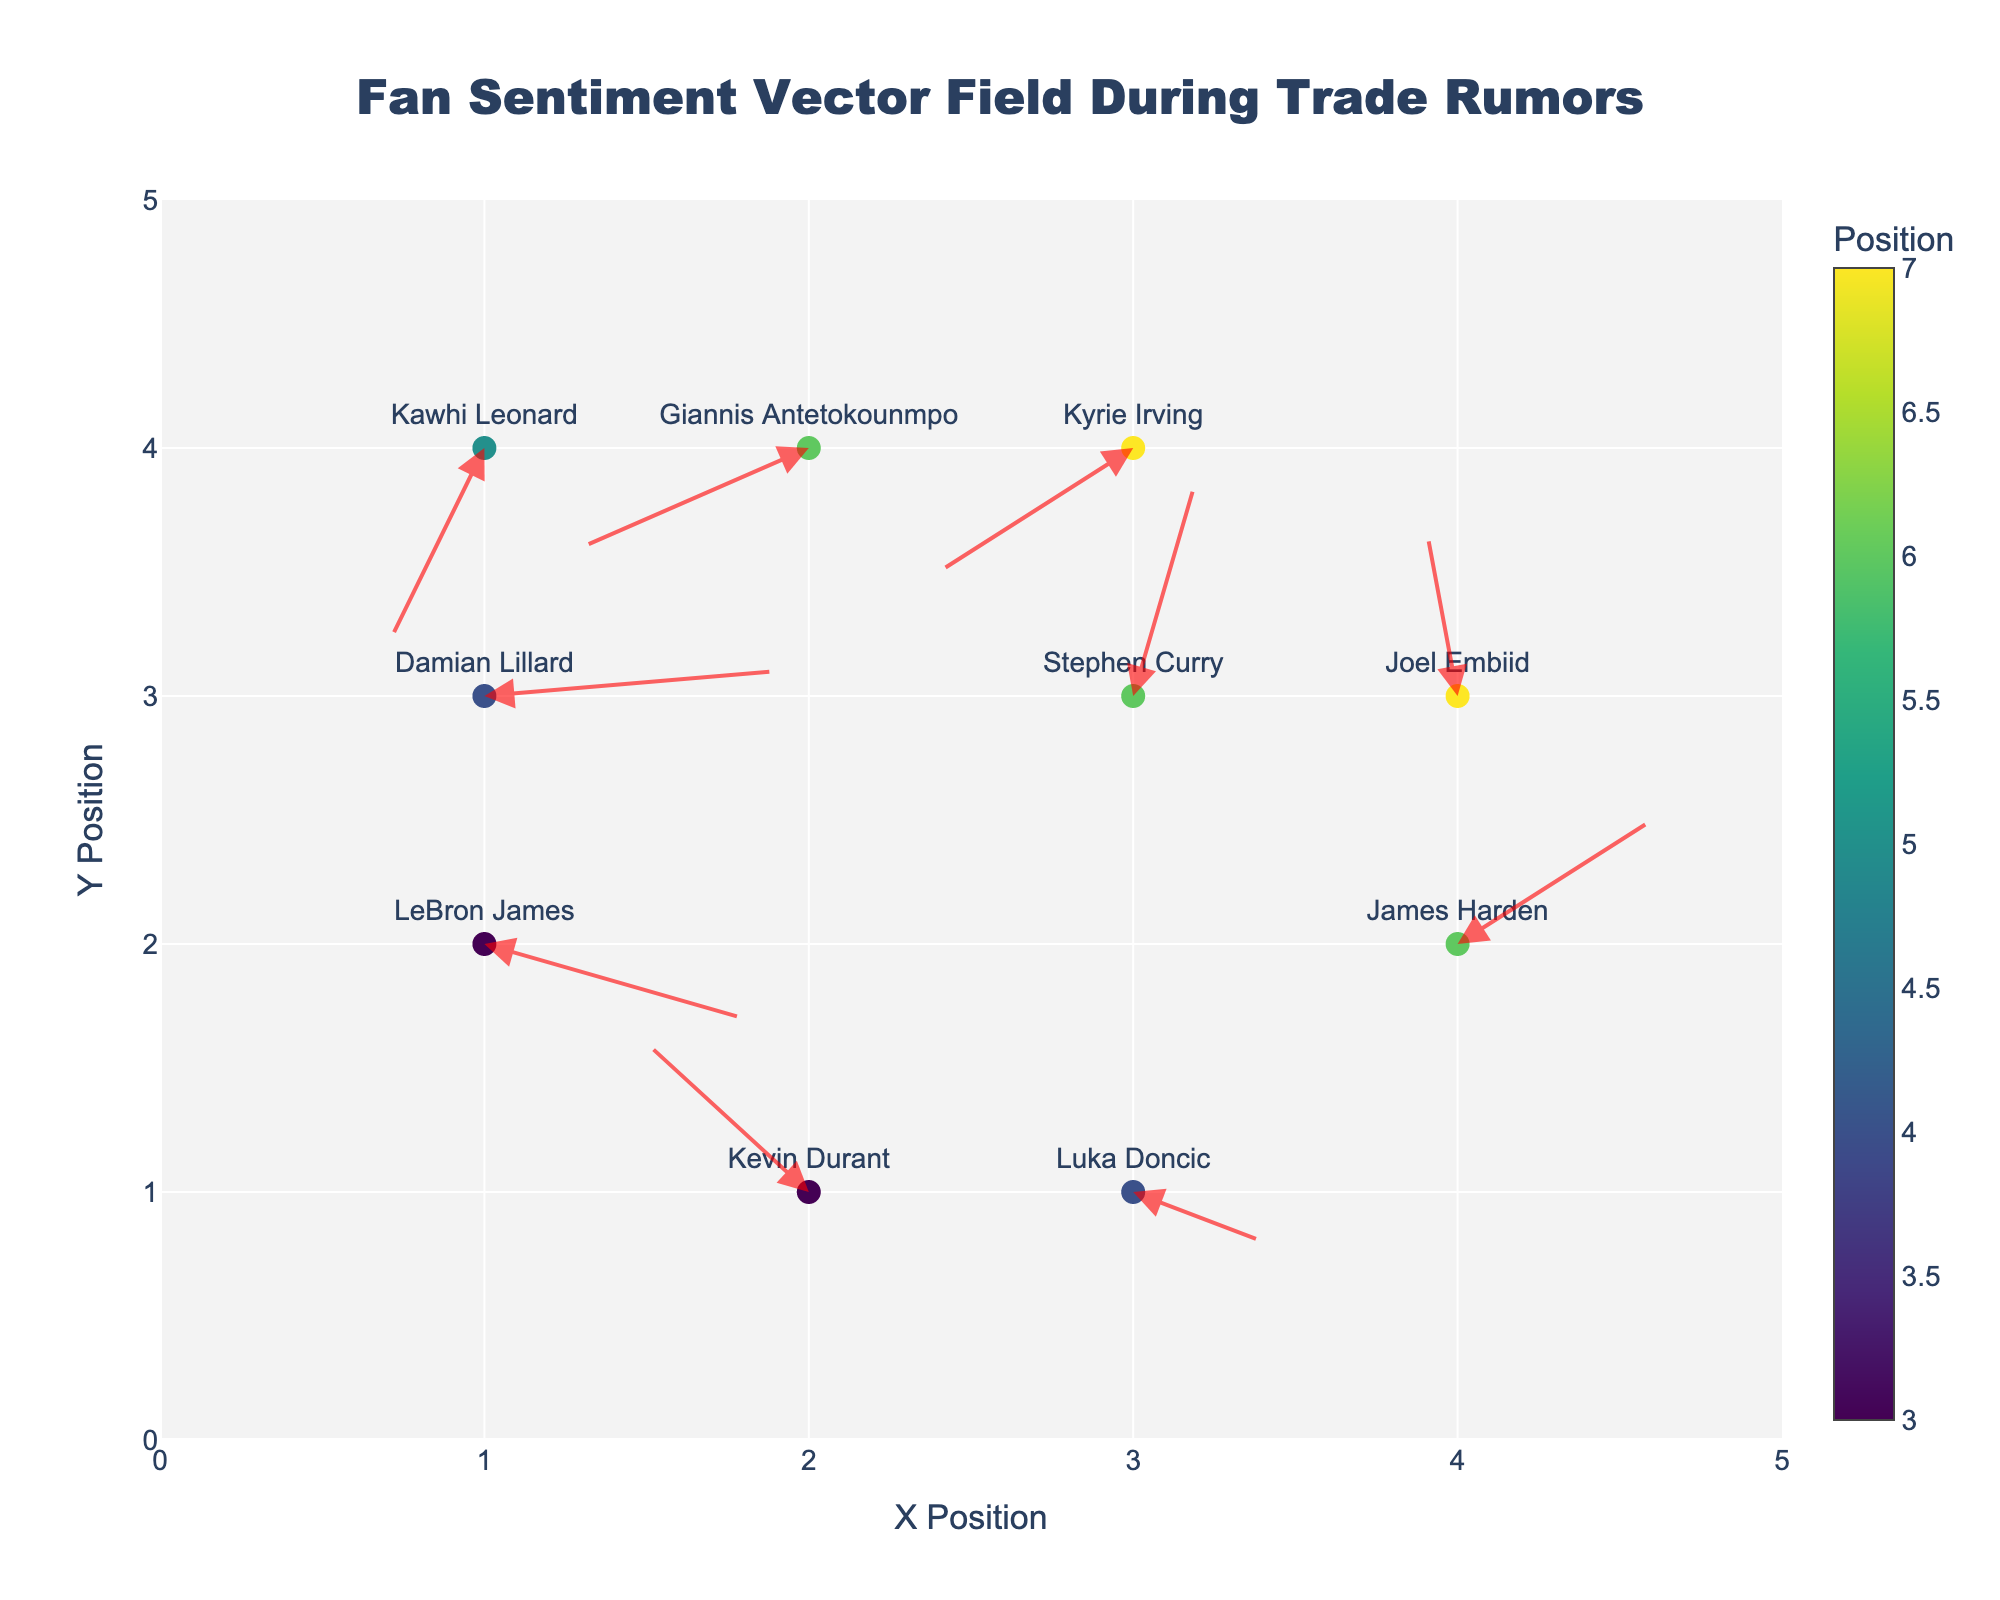What is the title of the quiver plot? The title is usually displayed prominently at the top center of the plot. In this case, it is "Fan Sentiment Vector Field During Trade Rumors" based on the figure's description.
Answer: "Fan Sentiment Vector Field During Trade Rumors" Which player has the highest X position in the plot? By referring to the player labels and their respective X positions, LeBron James has X = 1, Kevin Durant has X = 2, Stephen Curry has X = 3, Giannis Antetokounmpo has X = 2, James Harden has X = 4, and so on. James Harden, with X = 4, has the highest X position.
Answer: James Harden Which player shows the strongest negative sentiment (largest negative vector)? The direction and length of the sentiment vectors (U, V) can indicate the strength of the sentiment. The most negative combination is evidenced by the largest total vector magnitude in the negative direction. Kawhi Leonard has U = -0.3 and V = -0.8, giving a vector magnitude of √((-0.3)^2 + (-0.8)^2) ≈ 0.854.
Answer: Kawhi Leonard For Damian Lillard, what is the direction of the sentiment vector? Damian Lillard is located at X = 1, Y = 3 with vector components U = 0.9 and V = 0.1. The direction can be interpreted as predominantly positive in the horizontal (X) direction and slightly positive in the vertical (Y) direction.
Answer: Mostly positive horizontal, slightly positive vertical Which player shows a sentiment vector moving northwest (negative X, positive Y)? By analyzing the players and their sentiment vectors, Kevin Durant at X = 2, Y = 1 with U = -0.5 and V = 0.6 has a vector moving in the northwest direction.
Answer: Kevin Durant What is the average Y position of all players? Sum all Y positions: 2+1+3+4+2+4+1+3+3+4 = 27. There are 10 players, so the average is 27/10 = 2.7.
Answer: 2.7 Who has the longest sentiment vector? Calculate the magnitude of each sentiment vector using √(U^2 + V^2). For example, LeBron James's vector has a magnitude of √((0.8)^2 + (-0.3)^2) ≈ 0.854, and Stephen Curry's vector has √((0.2)^2 + (0.9)^2) ≈ 0.922. Stephen Curry with √((0.2)^2 + (0.9)^2) ≈ 0.922 has the longest vector.
Answer: Stephen Curry Compare the sentiment vectors of Stephen Curry and Kyrie Irving in terms of direction. Stephen Curry (X = 3, Y = 3) has a vector (U = 0.2, V = 0.9) moving mostly upwards, while Kyrie Irving (X = 3, Y = 4) has a vector (U = -0.6, V = -0.5) moving mostly downwards and to the left.
Answer: Stephen Curry's vector is mostly upwards, Kyrie Irving's vector is downwards and to the left Which player stands at position (4, 3)? By checking the list of player positions, Joel Embiid is at position (4, 3).
Answer: Joel Embiid Between LeBron James and Damian Lillard, who has the more positive sentiment? Compare the sentiment vectors: LeBron James (X = 1, Y = 2) with vector (U = 0.8, V = -0.3) and Damian Lillard (X = 1, Y = 3) with vector (U = 0.9, V = 0.1). Both vectors have positive X components, but Damian Lillard's vector has a positive Y component, indicating a more positive sentiment.
Answer: Damian Lillard 